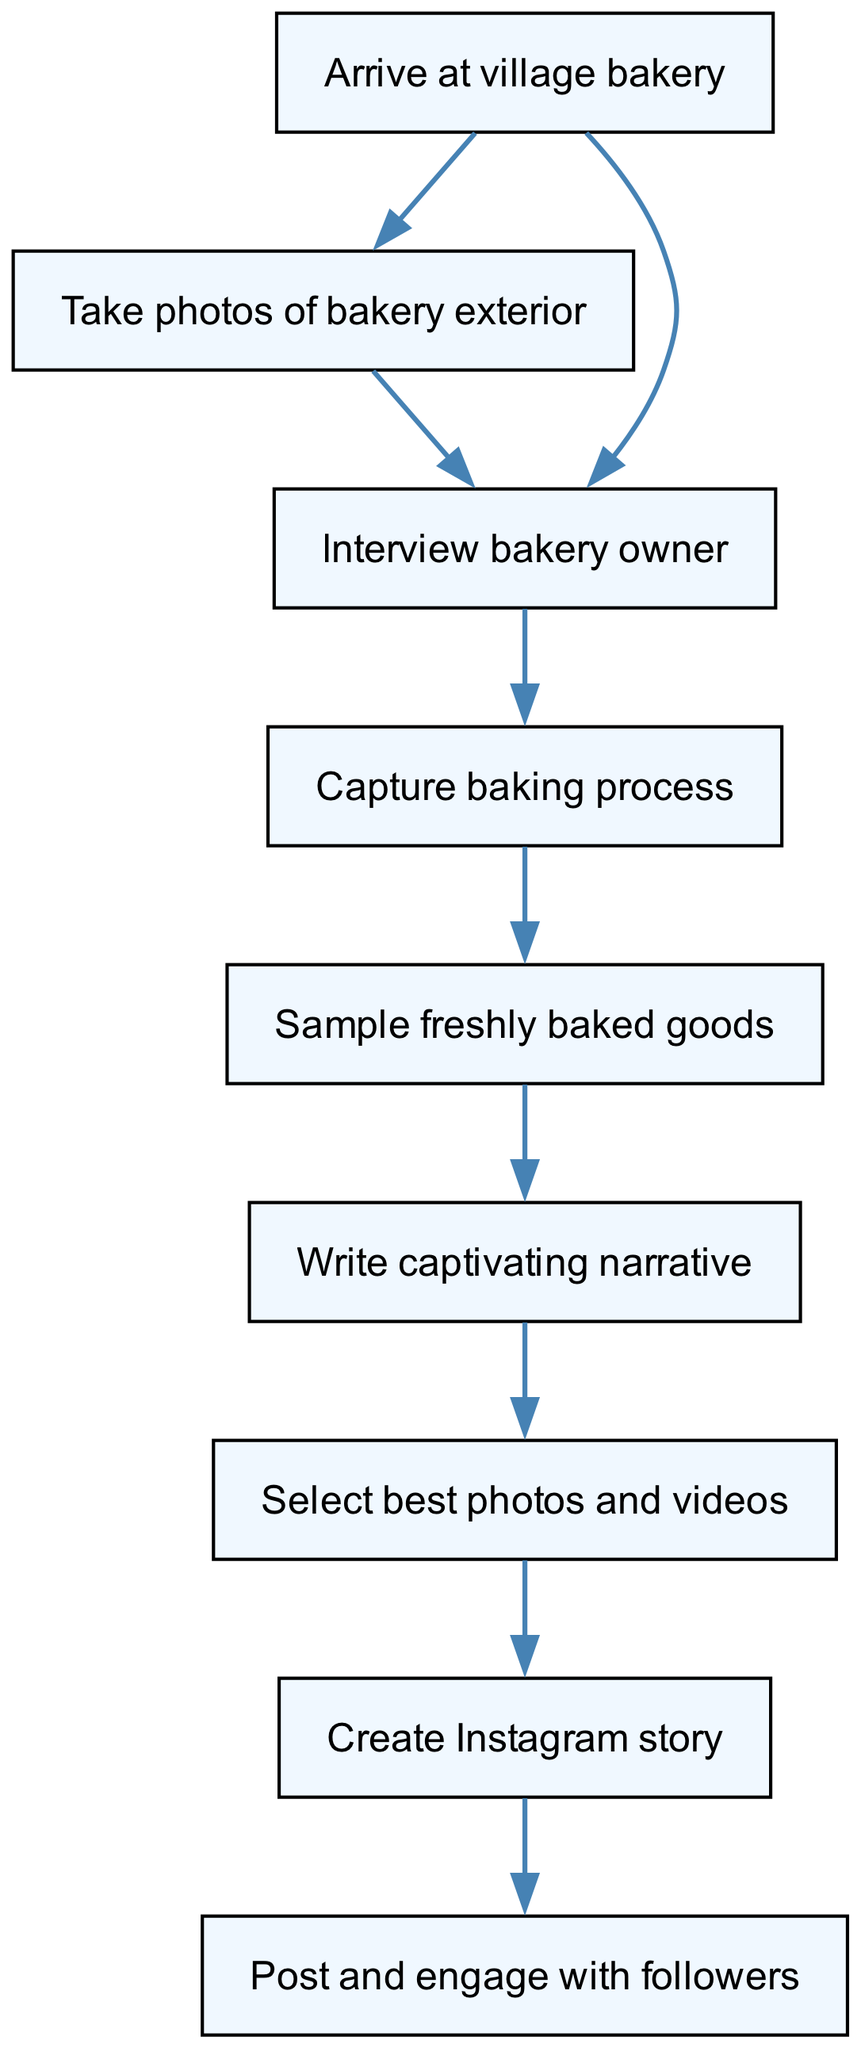What is the first step in the workflow? The first step in the workflow is represented by the first node, which states "Arrive at village bakery."
Answer: Arrive at village bakery How many total nodes are in the diagram? By counting each unique element under "elements," there are 9 nodes displayed in the diagram.
Answer: 9 What follows "Take photos of bakery exterior"? The next step after "Take photos of bakery exterior" is represented in the diagram by node 3, which states "Interview bakery owner."
Answer: Interview bakery owner Which step involves the tasting process? The step that includes tasting is represented in node 5, which is labeled "Sample freshly baked goods."
Answer: Sample freshly baked goods What is the last step before posting on Instagram? The last step prior to posting on Instagram is denoted as "Create Instagram story," which is node 8 in the flow.
Answer: Create Instagram story Which two steps come before selecting photos and videos? The two steps before selecting photos and videos involve "Write captivating narrative" in node 6 and "Sample freshly baked goods" in node 5, both leading to node 7.
Answer: Sample freshly baked goods, Write captivating narrative What action is taken immediately after capturing the baking process? The action taken immediately after "Capture baking process" is denoted by the next node which states "Sample freshly baked goods."
Answer: Sample freshly baked goods Which node represents the engagement with followers? The engagement with followers is represented by node 9, which is labeled "Post and engage with followers."
Answer: Post and engage with followers 